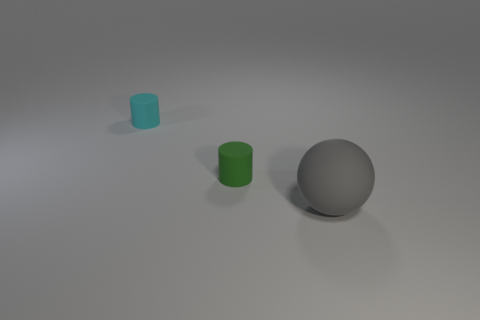Is there a small red sphere?
Give a very brief answer. No. There is a tiny cylinder that is behind the green matte object; how many big objects are in front of it?
Your answer should be very brief. 1. There is a gray matte thing that is on the right side of the tiny cyan rubber cylinder; what is its shape?
Offer a terse response. Sphere. The tiny cylinder that is on the right side of the tiny cylinder that is left of the cylinder that is in front of the tiny cyan thing is made of what material?
Your response must be concise. Rubber. How many other things are the same size as the gray matte thing?
Make the answer very short. 0. There is a cyan object that is the same shape as the green matte thing; what is its material?
Give a very brief answer. Rubber. The big object is what color?
Keep it short and to the point. Gray. There is a matte cylinder behind the cylinder on the right side of the tiny cyan rubber object; what is its color?
Your answer should be compact. Cyan. There is a small rubber thing in front of the tiny object on the left side of the tiny green matte object; what number of small things are on the left side of it?
Ensure brevity in your answer.  1. Are there any green objects right of the green matte cylinder?
Your answer should be compact. No. 